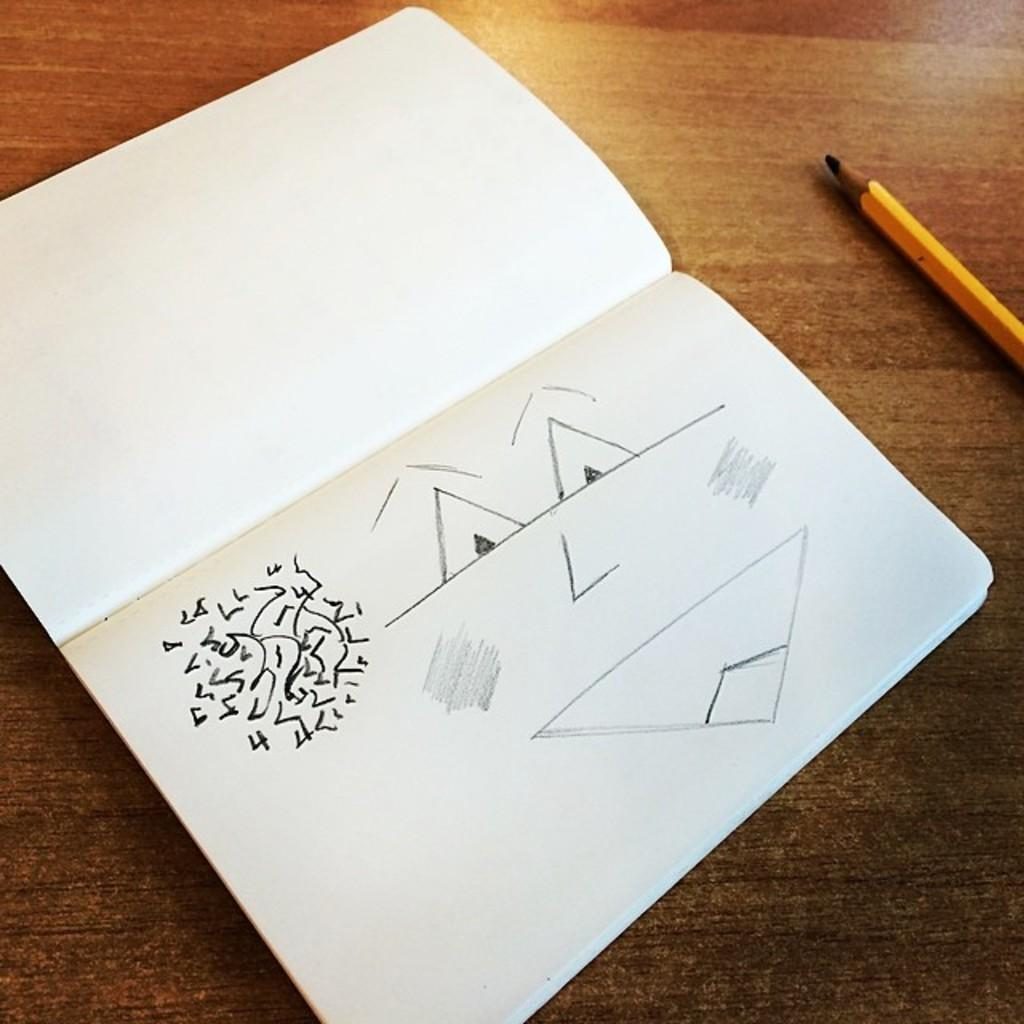What can be seen in the image related to reading or writing? There is a book and a yellow pencil in the image. What is the color of the table in the image? The table is brown in color. Can you describe what is drawn in the book? Unfortunately, the specifics of what is drawn in the book cannot be determined from the image. What might be used to write or draw in the book? The yellow pencil in the image could be used for writing or drawing. How many legs are visible on the loaf of bread in the image? There is no loaf of bread present in the image, so it is not possible to determine the number of legs on a loaf of bread. 